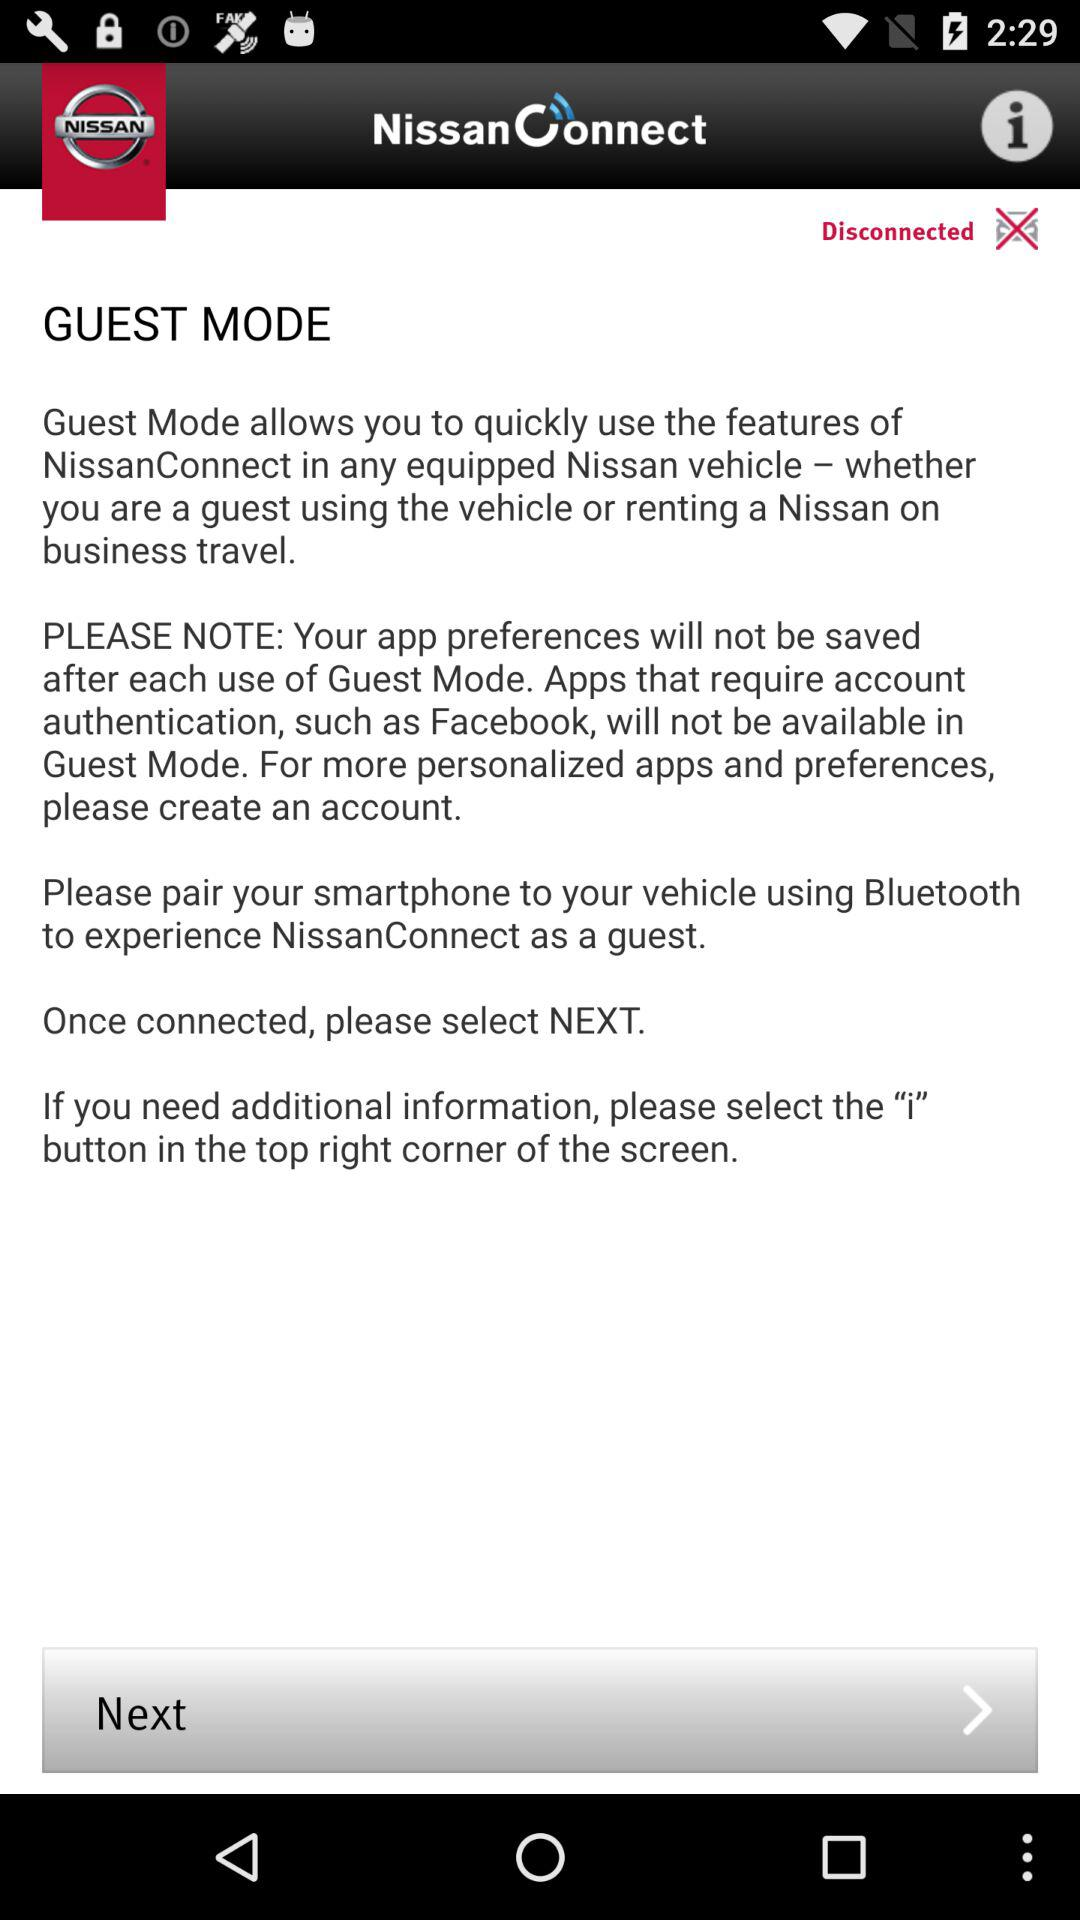What is the name of the application? The name of the application is "NissanConnect". 